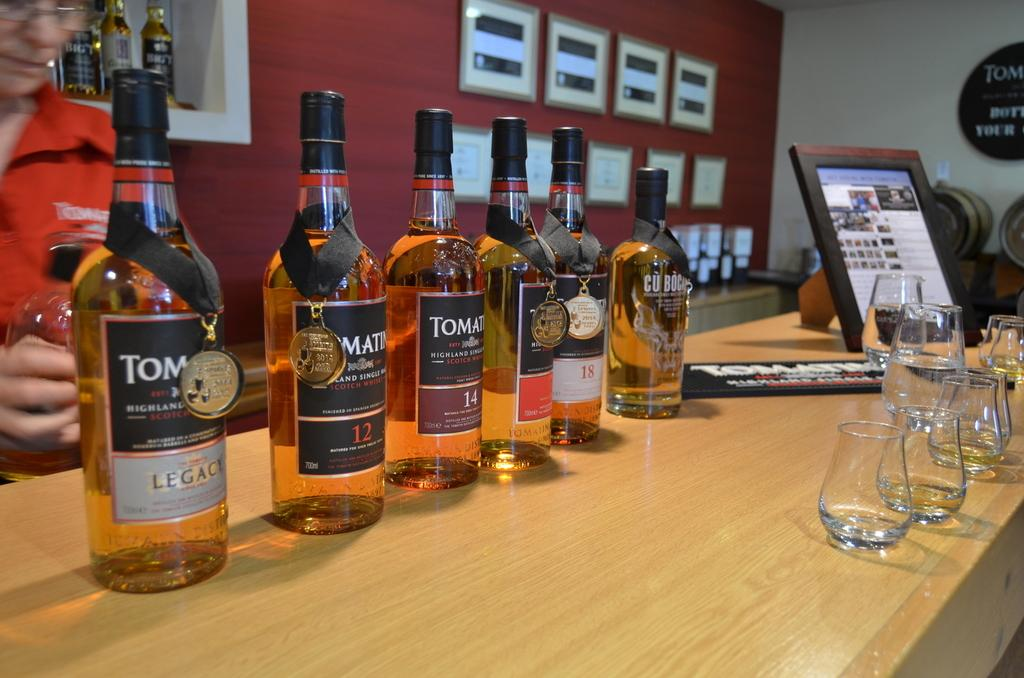<image>
Summarize the visual content of the image. Various bottles of Scotch are shown with medals, but Legacy is the first one in the line. 